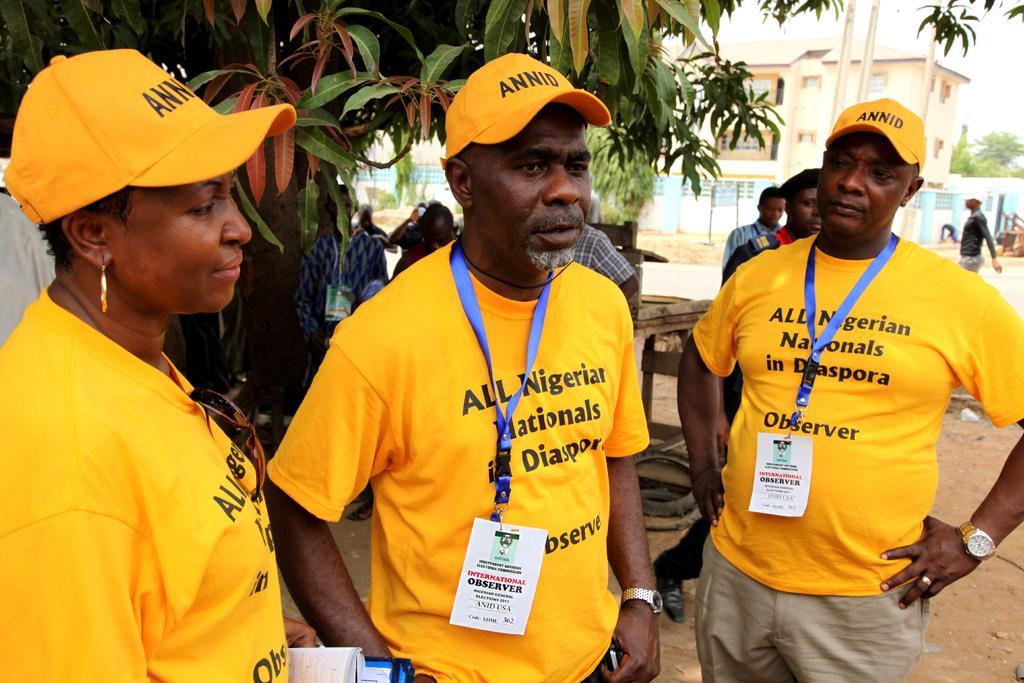Can you describe this image briefly? In this image we can see one building, one board with poles, some people are standing, some people are walking, some people are wearing ID cards, one white object on the left side of the image, some people are holding objects, some objects on the ground, some trees, some plants and grass on the ground. At the top there is the sky. 